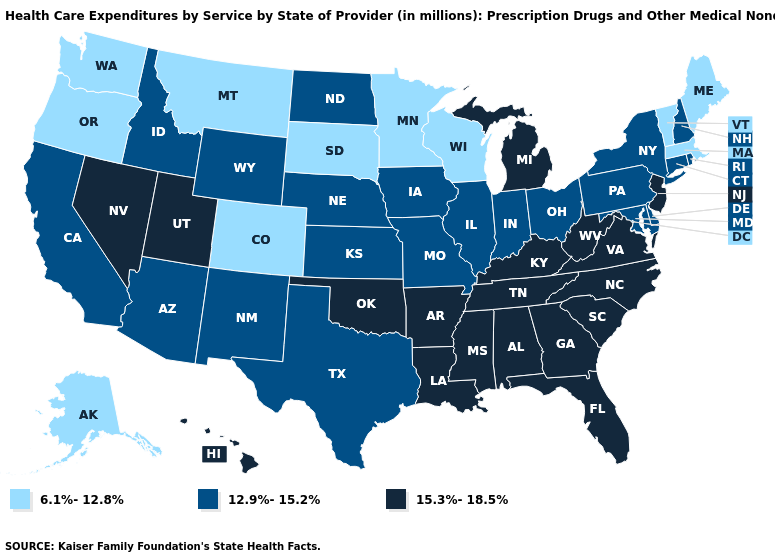Does Oregon have the highest value in the West?
Be succinct. No. What is the lowest value in the USA?
Short answer required. 6.1%-12.8%. What is the lowest value in states that border Kansas?
Write a very short answer. 6.1%-12.8%. What is the value of North Carolina?
Short answer required. 15.3%-18.5%. Is the legend a continuous bar?
Give a very brief answer. No. Which states hav the highest value in the West?
Be succinct. Hawaii, Nevada, Utah. Name the states that have a value in the range 15.3%-18.5%?
Keep it brief. Alabama, Arkansas, Florida, Georgia, Hawaii, Kentucky, Louisiana, Michigan, Mississippi, Nevada, New Jersey, North Carolina, Oklahoma, South Carolina, Tennessee, Utah, Virginia, West Virginia. Does Maine have the lowest value in the USA?
Answer briefly. Yes. Does Utah have the highest value in the West?
Quick response, please. Yes. What is the value of Nebraska?
Quick response, please. 12.9%-15.2%. Does Alaska have the lowest value in the USA?
Give a very brief answer. Yes. Name the states that have a value in the range 15.3%-18.5%?
Be succinct. Alabama, Arkansas, Florida, Georgia, Hawaii, Kentucky, Louisiana, Michigan, Mississippi, Nevada, New Jersey, North Carolina, Oklahoma, South Carolina, Tennessee, Utah, Virginia, West Virginia. Among the states that border New Mexico , which have the lowest value?
Keep it brief. Colorado. Name the states that have a value in the range 15.3%-18.5%?
Write a very short answer. Alabama, Arkansas, Florida, Georgia, Hawaii, Kentucky, Louisiana, Michigan, Mississippi, Nevada, New Jersey, North Carolina, Oklahoma, South Carolina, Tennessee, Utah, Virginia, West Virginia. How many symbols are there in the legend?
Be succinct. 3. 